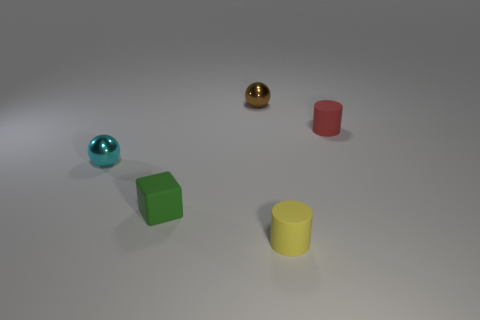What number of objects are cyan things or large purple shiny spheres?
Ensure brevity in your answer.  1. There is a shiny ball in front of the cylinder on the right side of the yellow matte cylinder; how many small cyan spheres are on the right side of it?
Your response must be concise. 0. Is there any other thing that has the same color as the matte cube?
Ensure brevity in your answer.  No. There is a tiny metallic thing that is in front of the brown shiny sphere; does it have the same color as the rubber cylinder behind the cyan shiny object?
Give a very brief answer. No. Are there more matte things to the left of the green thing than cyan shiny spheres that are behind the tiny cyan metallic sphere?
Your answer should be very brief. No. What material is the red thing?
Your answer should be very brief. Rubber. What is the shape of the tiny object right of the matte cylinder on the left side of the small rubber cylinder that is right of the tiny yellow thing?
Ensure brevity in your answer.  Cylinder. What number of other things are there of the same material as the tiny cyan thing
Your answer should be compact. 1. Does the ball that is on the right side of the tiny green matte object have the same material as the sphere that is in front of the tiny red thing?
Your answer should be compact. Yes. What number of tiny matte things are in front of the cyan ball and to the right of the tiny yellow cylinder?
Ensure brevity in your answer.  0. 